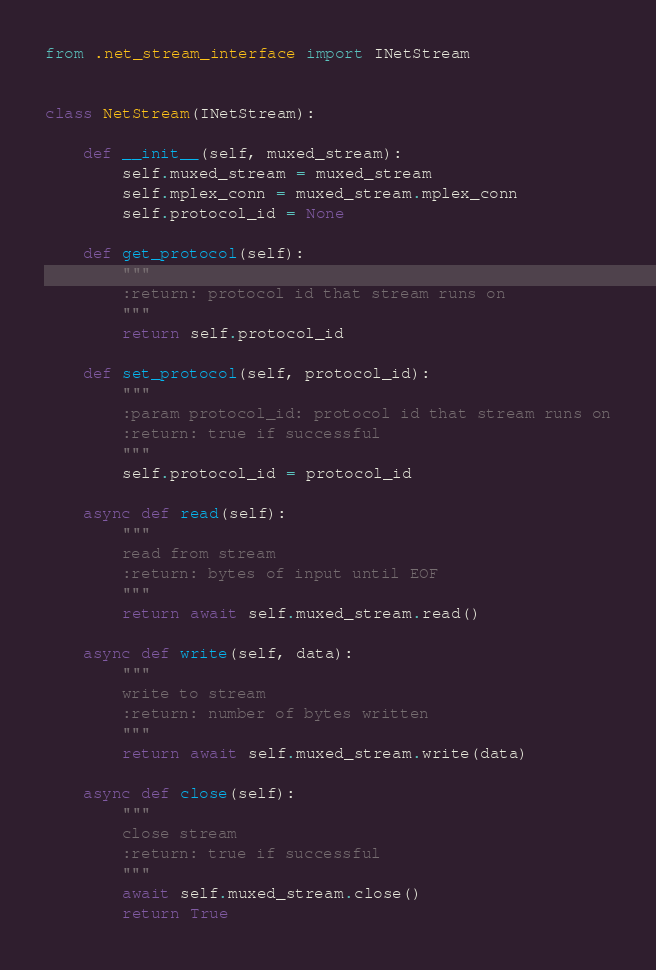Convert code to text. <code><loc_0><loc_0><loc_500><loc_500><_Python_>from .net_stream_interface import INetStream


class NetStream(INetStream):

    def __init__(self, muxed_stream):
        self.muxed_stream = muxed_stream
        self.mplex_conn = muxed_stream.mplex_conn
        self.protocol_id = None

    def get_protocol(self):
        """
        :return: protocol id that stream runs on
        """
        return self.protocol_id

    def set_protocol(self, protocol_id):
        """
        :param protocol_id: protocol id that stream runs on
        :return: true if successful
        """
        self.protocol_id = protocol_id

    async def read(self):
        """
        read from stream
        :return: bytes of input until EOF
        """
        return await self.muxed_stream.read()

    async def write(self, data):
        """
        write to stream
        :return: number of bytes written
        """
        return await self.muxed_stream.write(data)

    async def close(self):
        """
        close stream
        :return: true if successful
        """
        await self.muxed_stream.close()
        return True
</code> 